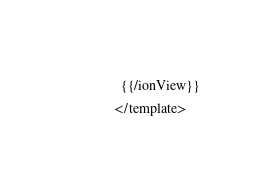Convert code to text. <code><loc_0><loc_0><loc_500><loc_500><_HTML_>  {{/ionView}}
</template></code> 